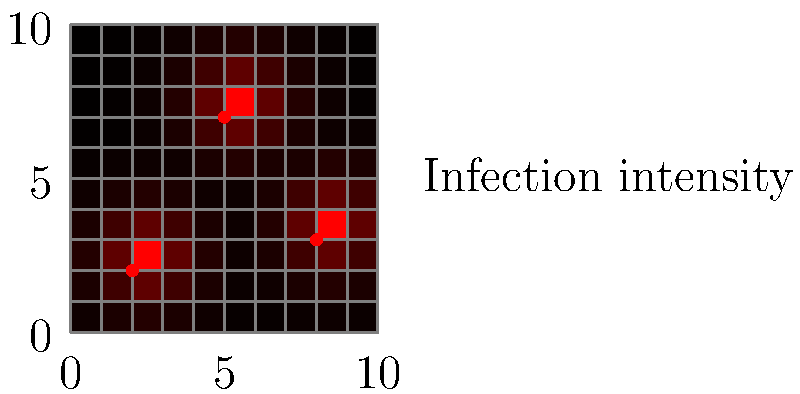Based on the 2D coordinate grid representing a field infected with a plant pathogen, where the red dots indicate initial infection points and the color intensity represents the spread of infection (darker red = higher infection), what is the approximate coordinate of the infection point that appears to have the most significant impact on the overall field infection? To determine the infection point with the most significant impact, we need to analyze the spread pattern and intensity around each initial infection point. Let's break it down step-by-step:

1. Identify the initial infection points:
   a. (2,2)
   b. (5,7)
   c. (8,3)

2. Assess the spread pattern around each point:
   a. (2,2): The infection spreads mostly to the bottom-left quadrant of the field.
   b. (5,7): The infection covers a large area in the upper-central part of the field.
   c. (8,3): The infection affects the bottom-right quadrant of the field.

3. Compare the intensity and extent of spread:
   a. (2,2): Moderate intensity, limited spread.
   b. (5,7): High intensity, extensive spread covering a significant portion of the field.
   c. (8,3): Moderate intensity, limited spread.

4. Evaluate the overall impact:
   The infection point at (5,7) shows the highest intensity and most extensive spread, affecting a larger area of the field compared to the other two points.

5. Consider the central location:
   The (5,7) point is more centrally located in the field, allowing for a more symmetrical spread of the infection.

Based on these observations, the infection point at approximately (5,7) appears to have the most significant impact on the overall field infection.
Answer: (5,7) 